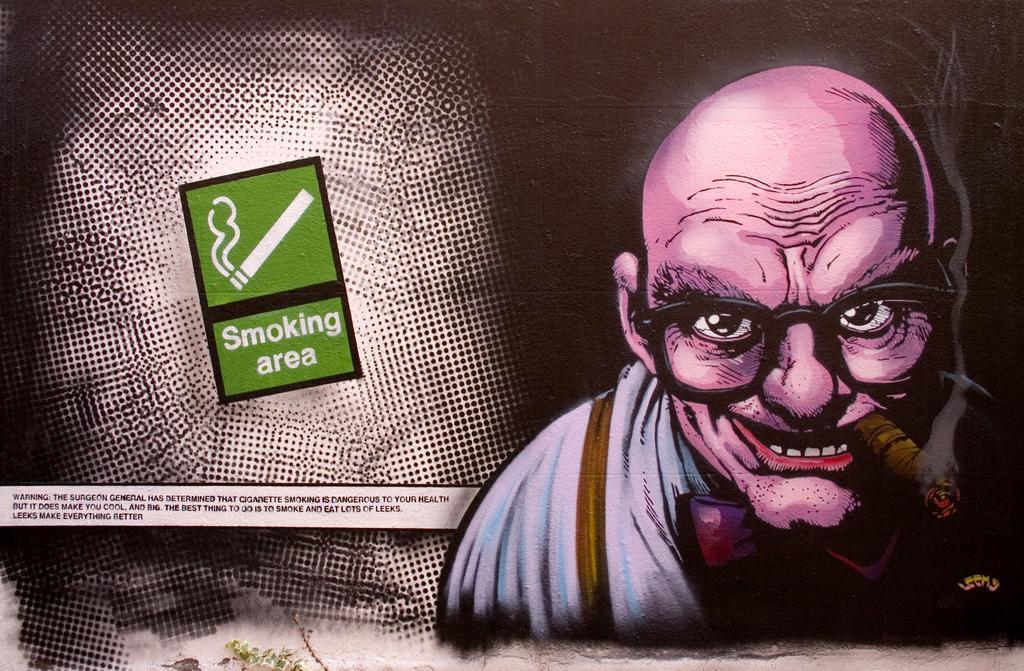Please provide a concise description of this image. In the image we can see an animated picture of a person, wearing clothes, spectacles and holding an object in his mouth. There is a text and a symbol of cigarette. 